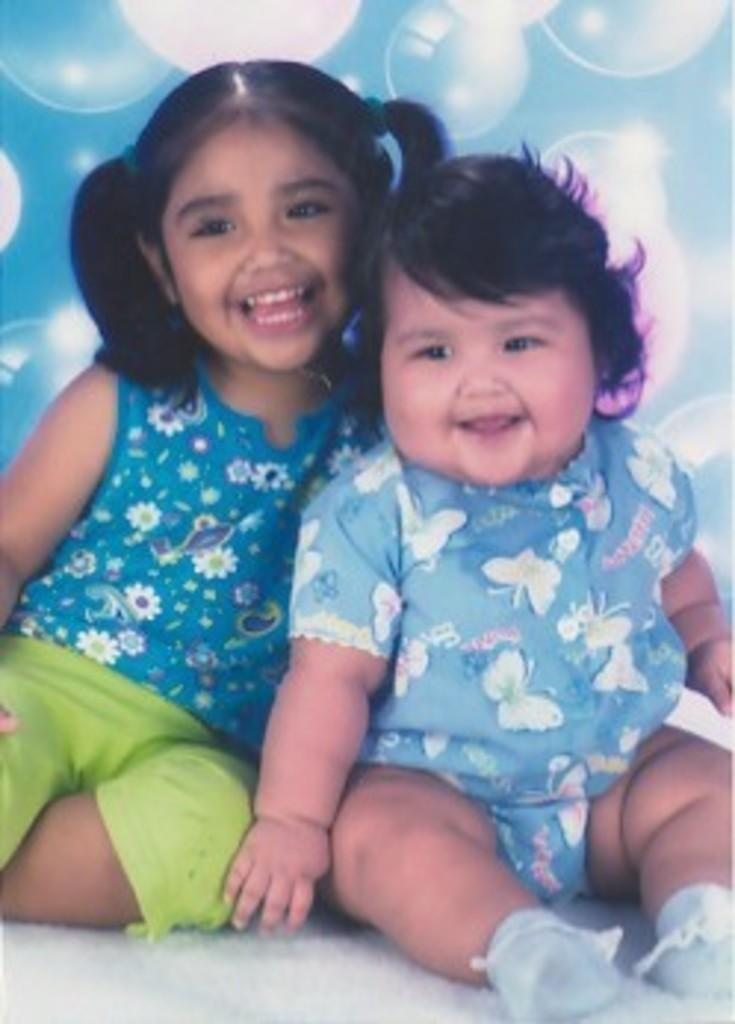Who are the subjects in the image? There is a baby and a girl in the image. What are the subjects doing in the image? Both the baby and the girl are sitting and smiling. What can be seen in the background of the image? There is a wall with designs. What type of wire is being used by the doctor in the image? There is no doctor or wire present in the image; it features a baby and a girl sitting and smiling. 